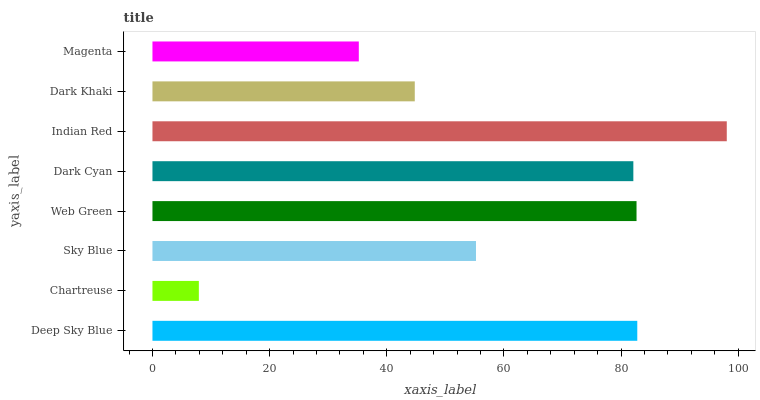Is Chartreuse the minimum?
Answer yes or no. Yes. Is Indian Red the maximum?
Answer yes or no. Yes. Is Sky Blue the minimum?
Answer yes or no. No. Is Sky Blue the maximum?
Answer yes or no. No. Is Sky Blue greater than Chartreuse?
Answer yes or no. Yes. Is Chartreuse less than Sky Blue?
Answer yes or no. Yes. Is Chartreuse greater than Sky Blue?
Answer yes or no. No. Is Sky Blue less than Chartreuse?
Answer yes or no. No. Is Dark Cyan the high median?
Answer yes or no. Yes. Is Sky Blue the low median?
Answer yes or no. Yes. Is Sky Blue the high median?
Answer yes or no. No. Is Dark Cyan the low median?
Answer yes or no. No. 